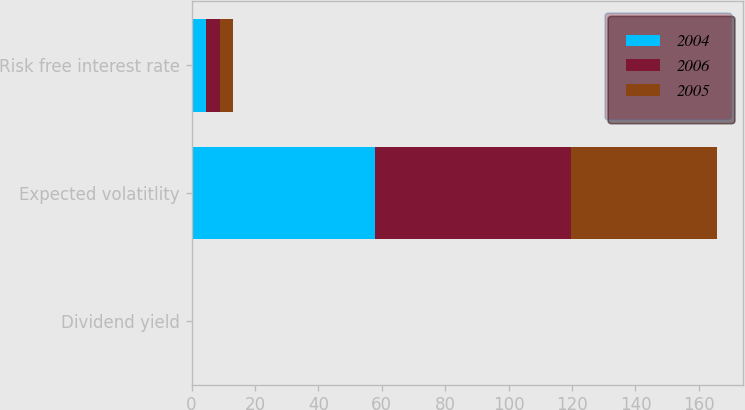<chart> <loc_0><loc_0><loc_500><loc_500><stacked_bar_chart><ecel><fcel>Dividend yield<fcel>Expected volatitlity<fcel>Risk free interest rate<nl><fcel>2004<fcel>0<fcel>57.7<fcel>4.7<nl><fcel>2006<fcel>0<fcel>62<fcel>4.4<nl><fcel>2005<fcel>0<fcel>46<fcel>4<nl></chart> 